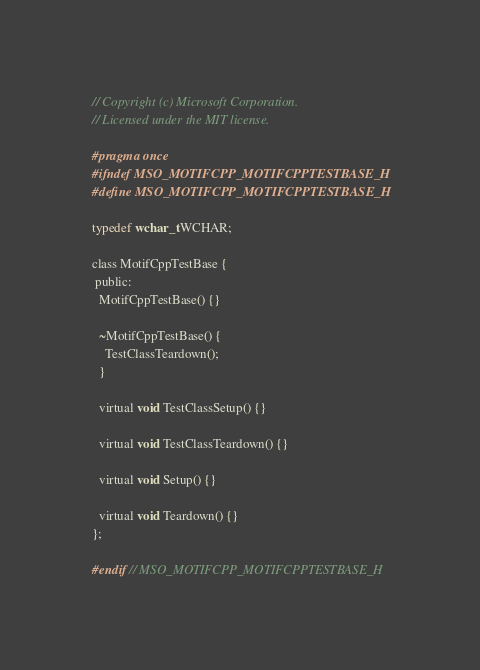Convert code to text. <code><loc_0><loc_0><loc_500><loc_500><_C_>// Copyright (c) Microsoft Corporation.
// Licensed under the MIT license.

#pragma once
#ifndef MSO_MOTIFCPP_MOTIFCPPTESTBASE_H
#define MSO_MOTIFCPP_MOTIFCPPTESTBASE_H

typedef wchar_t WCHAR;

class MotifCppTestBase {
 public:
  MotifCppTestBase() {}

  ~MotifCppTestBase() {
    TestClassTeardown();
  }

  virtual void TestClassSetup() {}

  virtual void TestClassTeardown() {}

  virtual void Setup() {}

  virtual void Teardown() {}
};

#endif // MSO_MOTIFCPP_MOTIFCPPTESTBASE_H
</code> 